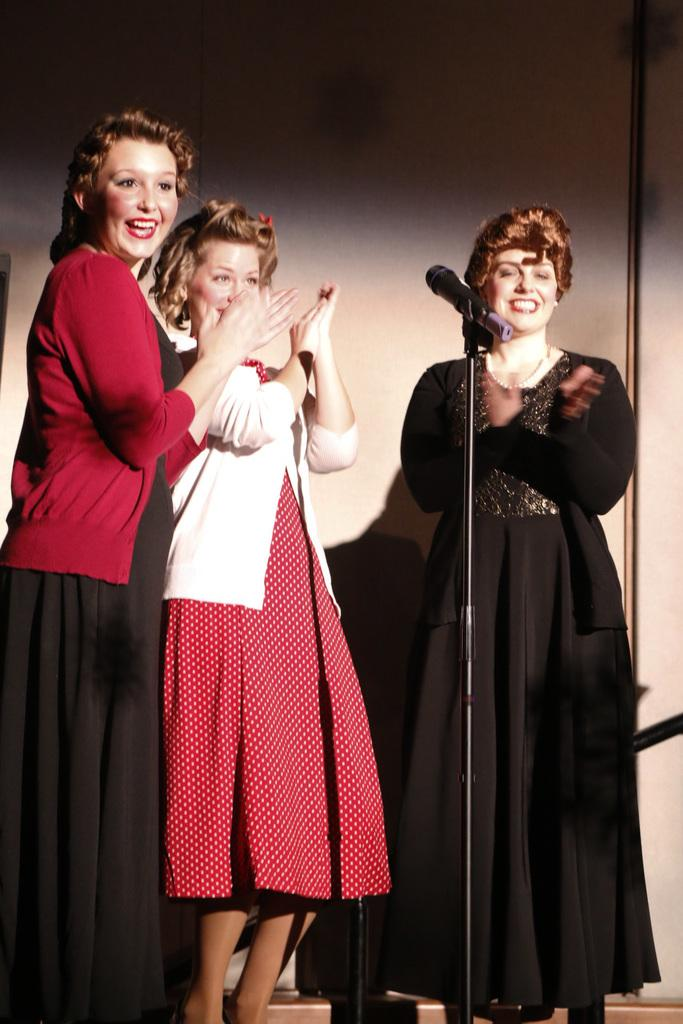What can be seen in the image? There are women standing in the image. What is in front of the women? There is a microphone (mic) in front of the women. What is visible in the background of the image? There is a wall in the background of the image. What type of grain is being poured into the bottle in the image? There is no grain or bottle present in the image. 